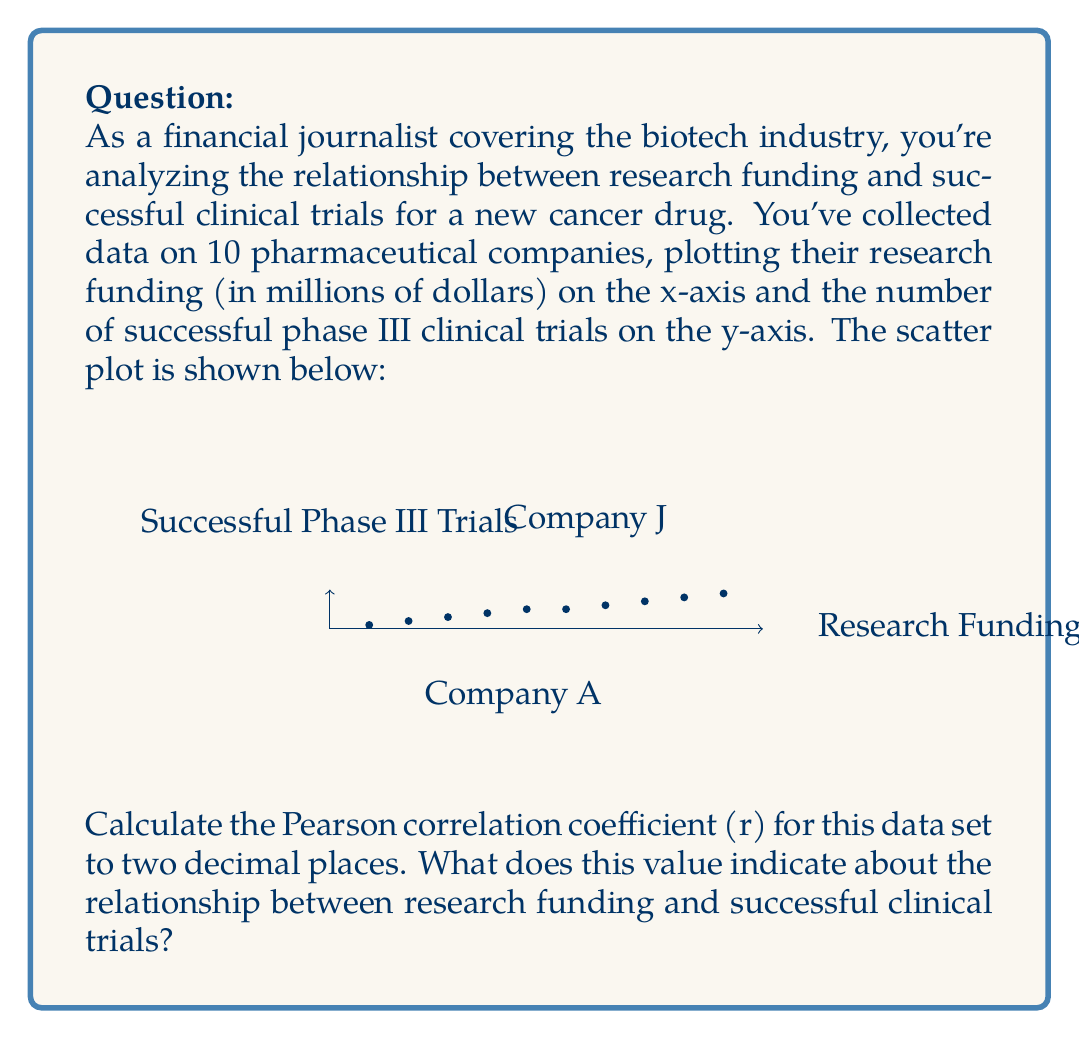Provide a solution to this math problem. To calculate the Pearson correlation coefficient (r), we'll follow these steps:

1. Calculate the means of x and y:
   $\bar{x} = \frac{\sum x_i}{n} = \frac{550}{10} = 55$
   $\bar{y} = \frac{\sum y_i}{n} = \frac{50}{10} = 5$

2. Calculate the deviations from the mean:
   $x_i - \bar{x}$ and $y_i - \bar{y}$ for each data point

3. Calculate the products of the deviations:
   $(x_i - \bar{x})(y_i - \bar{y})$ for each data point

4. Sum the products of deviations:
   $\sum (x_i - \bar{x})(y_i - \bar{y}) = 2475$

5. Calculate the sum of squared deviations for x and y:
   $\sum (x_i - \bar{x})^2 = 8250$
   $\sum (y_i - \bar{y})^2 = 60$

6. Apply the formula for Pearson correlation coefficient:

   $$r = \frac{\sum (x_i - \bar{x})(y_i - \bar{y})}{\sqrt{\sum (x_i - \bar{x})^2 \sum (y_i - \bar{y})^2}}$$

   $$r = \frac{2475}{\sqrt{8250 \times 60}} = \frac{2475}{\sqrt{495000}} = \frac{2475}{703.56} = 0.9879$$

7. Round to two decimal places: r = 0.99

This value indicates a very strong positive correlation between research funding and successful clinical trials. As research funding increases, the number of successful phase III clinical trials tends to increase as well, with a nearly perfect linear relationship.
Answer: r = 0.99, indicating a very strong positive correlation 